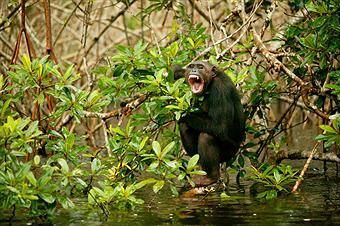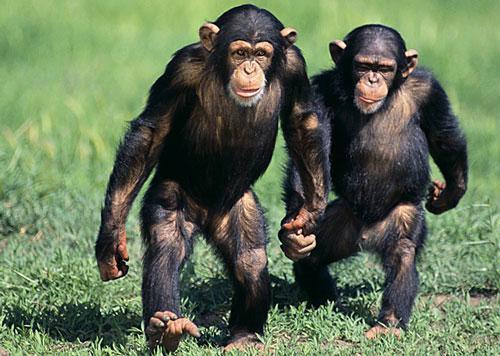The first image is the image on the left, the second image is the image on the right. Assess this claim about the two images: "An image shows exactly one chimp, in a squatting position with forearms on knees.". Correct or not? Answer yes or no. Yes. 